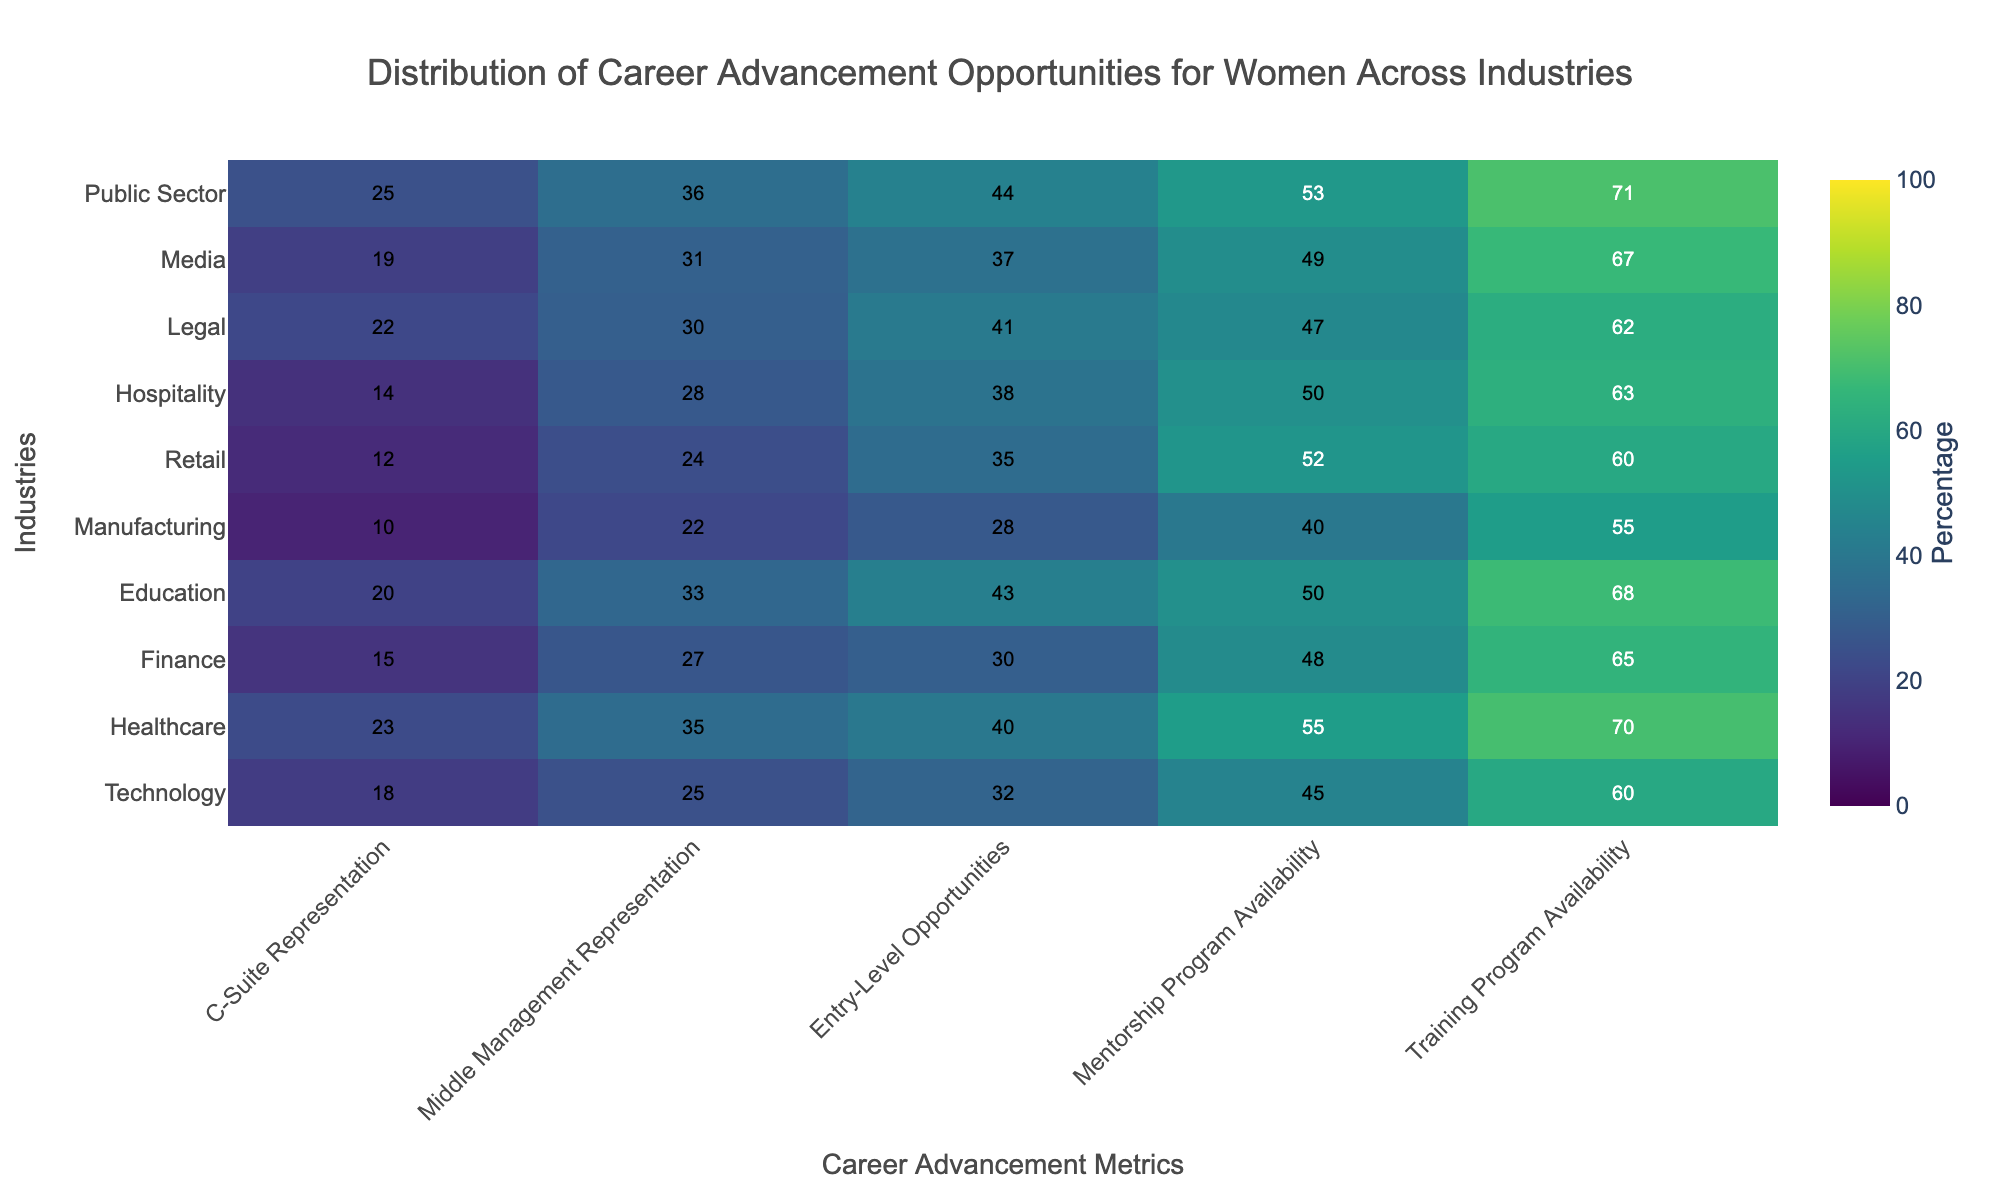What is the highest C-Suite representation percentage for women among the industries? To find this, look at the "C-Suite Representation" column and identify the highest percentage. In this case, it is Healthcare.
Answer: Healthcare with 23% Which industry has the lowest entry-level opportunities for women? Check the "Entry-Level Opportunities" column and find the minimum value. The manufacturing industry has the lowest value.
Answer: Manufacturing with 28% What are the percentages associated with the public sector under mentorship and training program availability? Locate the public sector in the "Industry" column, then read the values under "Mentorship Program Availability" and "Training Program Availability." They are 53% and 71%, respectively.
Answer: Mentorship: 53%, Training: 71% Compare the middle management representation for Technology and Healthcare. Which one has a higher percentage? Refer to the "Middle Management Representation" column for Technology and Healthcare. Technology is 25% and Healthcare is 35%.
Answer: Healthcare What is the average percentage of mentorship program availability across all industries? Add the values for "Mentorship Program Availability" and divide by the number of industries: (45 + 55 + 48 + 50 + 40 + 52 + 50 + 47 + 49 + 53) / 10 = 48.9.
Answer: 48.9% Which industry shows the most balanced distribution across all career advancement metrics? Look at all the columns for each industry and identify the one with the least variation among its metrics. The public sector appears balanced with percentages ranging from 25% to 71%.
Answer: Public Sector For the industries where training program availability is above 60%, what is the average middle management representation percentage? Identify industries where "Training Program Availability" > 60%: Technology, Healthcare, Finance, Education, Media, Public Sector. Calculate the average middle management representation for these: (25 + 35 + 27 + 33 + 31 + 36) / 6 = 31.17.
Answer: 31.17% How much higher is Healthcare's entry-level opportunities compared to Finance? Subtract the entry-level opportunities value for Finance from Healthcare: 40 - 30 = 10.
Answer: 10% Which metric has the most consistent values across all industries? Observe each column to identify the one with the least variability. "Mentorship Program Availability" and "Training Program Availability" show the most consistent values.
Answer: Mentorship and Training Program Availability 